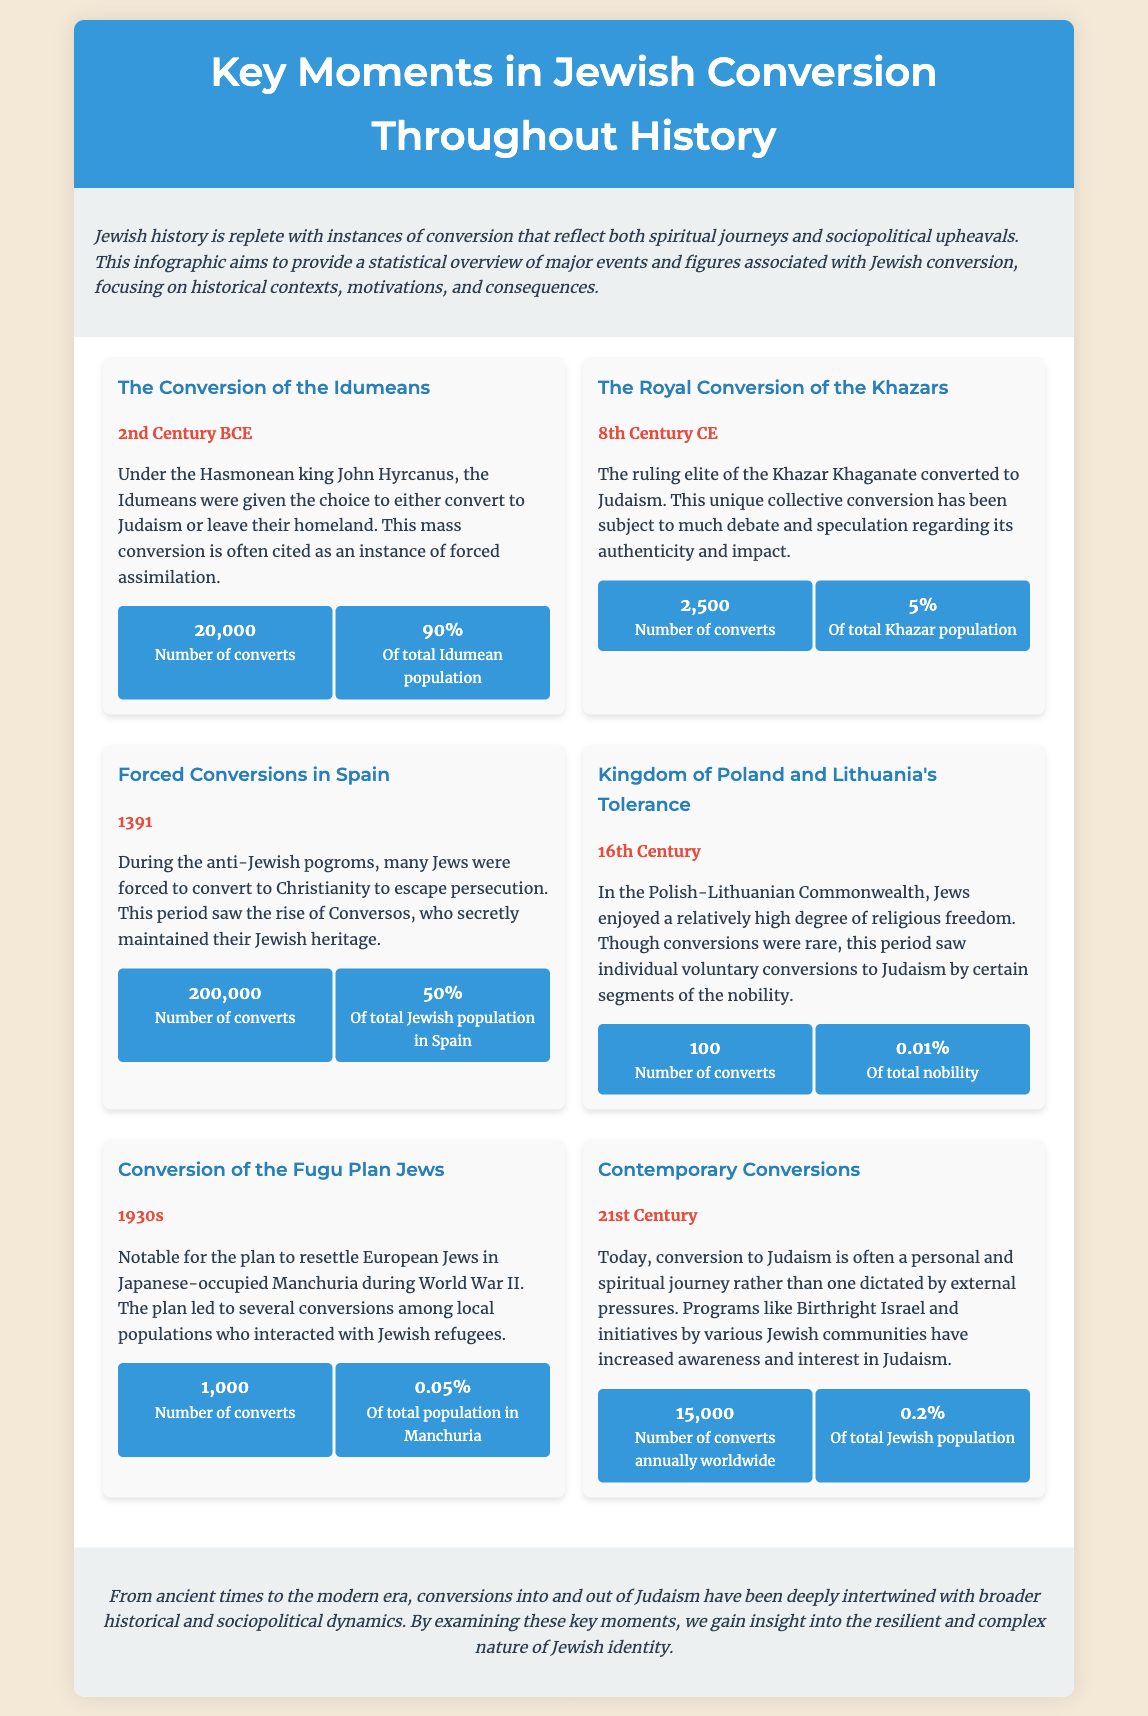What was the year of the conversion of the Idumeans? The document states that the conversion of the Idumeans occurred in the 2nd Century BCE.
Answer: 2nd Century BCE How many converts resulted from the forced conversions in Spain? According to the document, during the forced conversions in Spain, the number of converts was 200,000.
Answer: 200,000 What percentage of the Khazar population converted to Judaism? The document indicates that 5% of the total Khazar population converted to Judaism.
Answer: 5% What event is associated with the year 1930s? The document cites the Conversion of the Fugu Plan Jews as the event associated with the 1930s.
Answer: Conversion of the Fugu Plan Jews What unique circumstance characterized the royal conversion of the Khazars? It was a unique collective conversion by the ruling elite of the Khazar Khaganate.
Answer: Collective conversion How many converts are noted in the 21st century? The document notes that there are 15,000 converts annually worldwide in the 21st century.
Answer: 15,000 Which period saw individual voluntary conversions to Judaism? The 16th Century is mentioned as the period when individual voluntary conversions occurred.
Answer: 16th Century What was the total percentage of the Jewish population in Spain that converted due to forced conversions? The document reports that 50% of the total Jewish population in Spain converted during forced conversions.
Answer: 50% 